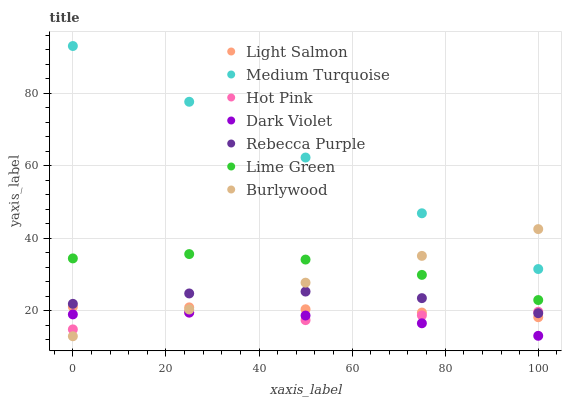Does Dark Violet have the minimum area under the curve?
Answer yes or no. Yes. Does Medium Turquoise have the maximum area under the curve?
Answer yes or no. Yes. Does Burlywood have the minimum area under the curve?
Answer yes or no. No. Does Burlywood have the maximum area under the curve?
Answer yes or no. No. Is Burlywood the smoothest?
Answer yes or no. Yes. Is Hot Pink the roughest?
Answer yes or no. Yes. Is Hot Pink the smoothest?
Answer yes or no. No. Is Burlywood the roughest?
Answer yes or no. No. Does Burlywood have the lowest value?
Answer yes or no. Yes. Does Hot Pink have the lowest value?
Answer yes or no. No. Does Medium Turquoise have the highest value?
Answer yes or no. Yes. Does Burlywood have the highest value?
Answer yes or no. No. Is Light Salmon less than Rebecca Purple?
Answer yes or no. Yes. Is Medium Turquoise greater than Dark Violet?
Answer yes or no. Yes. Does Burlywood intersect Lime Green?
Answer yes or no. Yes. Is Burlywood less than Lime Green?
Answer yes or no. No. Is Burlywood greater than Lime Green?
Answer yes or no. No. Does Light Salmon intersect Rebecca Purple?
Answer yes or no. No. 